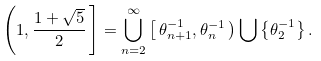Convert formula to latex. <formula><loc_0><loc_0><loc_500><loc_500>\left ( 1 , \frac { 1 + \sqrt { 5 } } { 2 } \, \right ] = \bigcup _ { n = 2 } ^ { \infty } \left [ \, \theta _ { n + 1 } ^ { - 1 } , \theta _ { n } ^ { - 1 } \, \right ) \bigcup \left \{ \theta _ { 2 } ^ { - 1 } \right \} .</formula> 